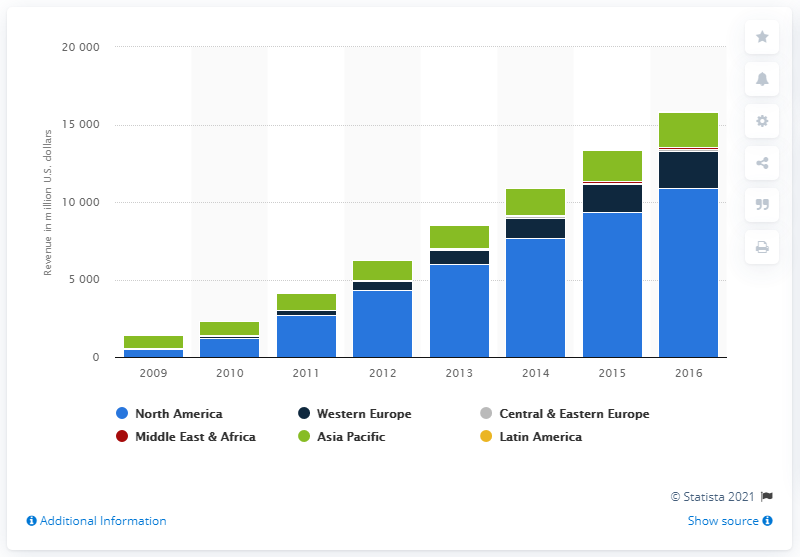Highlight a few significant elements in this photo. In 2016, the forecast for e-book revenue in North America was 10,905. 